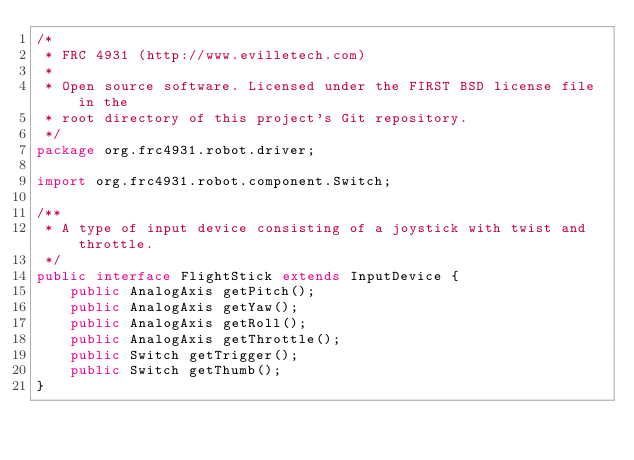<code> <loc_0><loc_0><loc_500><loc_500><_Java_>/*
 * FRC 4931 (http://www.evilletech.com)
 *
 * Open source software. Licensed under the FIRST BSD license file in the
 * root directory of this project's Git repository.
 */
package org.frc4931.robot.driver;

import org.frc4931.robot.component.Switch;

/**
 * A type of input device consisting of a joystick with twist and throttle.
 */
public interface FlightStick extends InputDevice {
    public AnalogAxis getPitch();
    public AnalogAxis getYaw();
    public AnalogAxis getRoll();
    public AnalogAxis getThrottle();
    public Switch getTrigger();
    public Switch getThumb();
}
</code> 